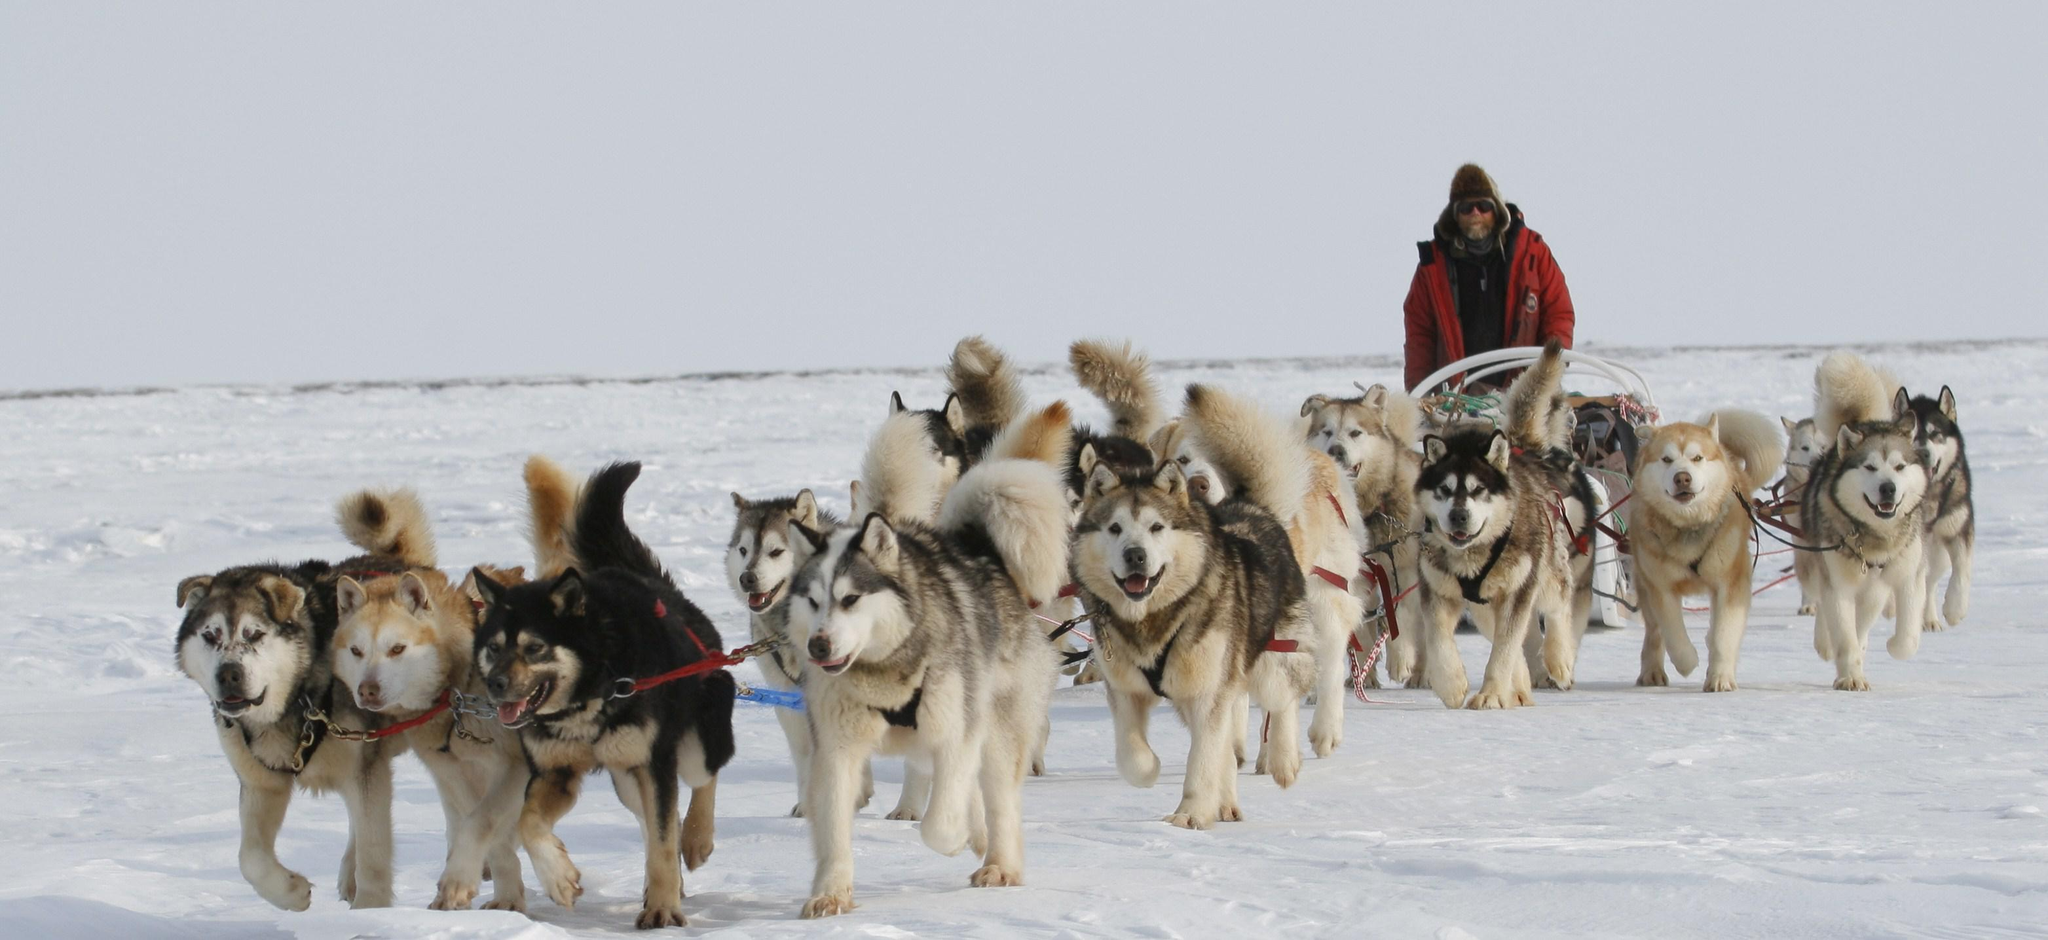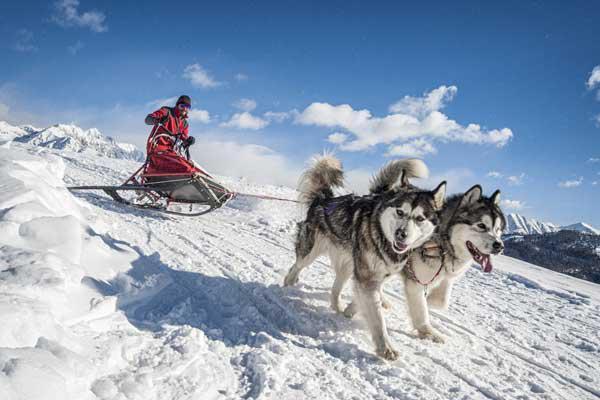The first image is the image on the left, the second image is the image on the right. Given the left and right images, does the statement "One dog team with a sled driver standing in back is headed forward and to the left down snowy ground with no bystanders." hold true? Answer yes or no. Yes. The first image is the image on the left, the second image is the image on the right. For the images shown, is this caption "There are only two dogs pulling one of the sleds." true? Answer yes or no. Yes. 